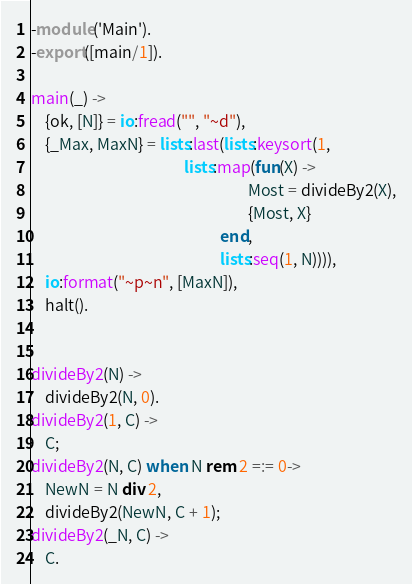Convert code to text. <code><loc_0><loc_0><loc_500><loc_500><_Erlang_>-module('Main').
-export([main/1]).

main(_) ->
    {ok, [N]} = io:fread("", "~d"),
    {_Max, MaxN} = lists:last(lists:keysort(1,
                                           lists:map(fun(X) ->
                                                             Most = divideBy2(X),
                                                             {Most, X}
                                                     end,
                                                     lists:seq(1, N)))),
    io:format("~p~n", [MaxN]),
    halt().


divideBy2(N) ->
    divideBy2(N, 0).
divideBy2(1, C) ->
    C;
divideBy2(N, C) when N rem 2 =:= 0->
    NewN = N div 2,
    divideBy2(NewN, C + 1);
divideBy2(_N, C) ->
    C.

</code> 